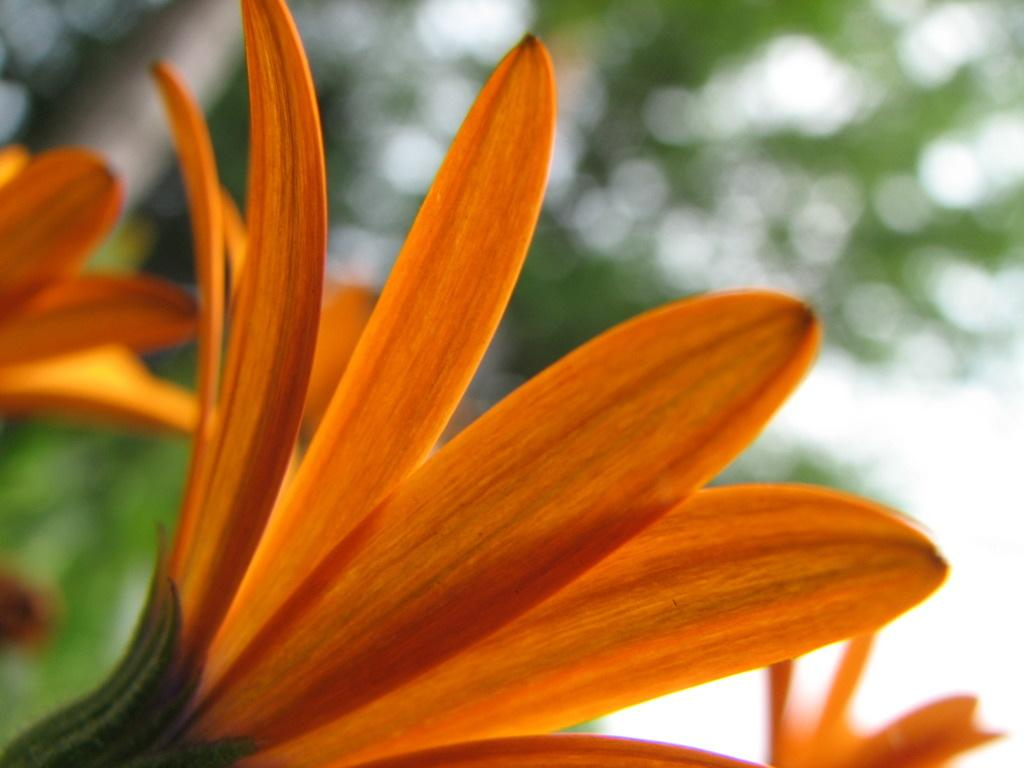How many flowers are present in the image? There are two flowers in the image. What color are the flowers? The flowers are orange in color. What are the main features of the flowers? The flowers have petals. Can you describe the background of the image? The background of the image appears blurry. What type of noise does the flower make in the image? Flowers do not make noise, so there is no noise present in the image. 